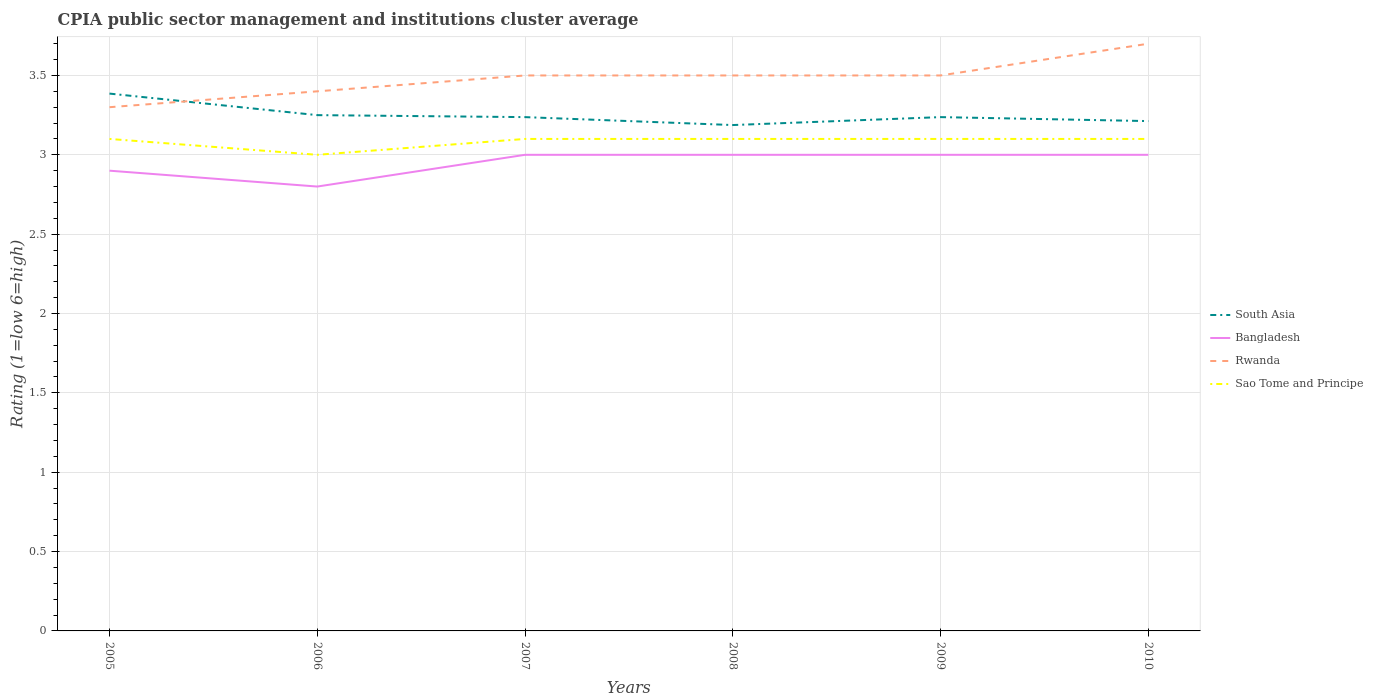How many different coloured lines are there?
Offer a very short reply. 4. Does the line corresponding to South Asia intersect with the line corresponding to Sao Tome and Principe?
Provide a short and direct response. No. In which year was the CPIA rating in South Asia maximum?
Keep it short and to the point. 2008. What is the total CPIA rating in Rwanda in the graph?
Provide a succinct answer. -0.1. What is the difference between the highest and the second highest CPIA rating in Rwanda?
Provide a succinct answer. 0.4. What is the difference between the highest and the lowest CPIA rating in Bangladesh?
Ensure brevity in your answer.  4. How many years are there in the graph?
Offer a terse response. 6. Are the values on the major ticks of Y-axis written in scientific E-notation?
Make the answer very short. No. Does the graph contain grids?
Your response must be concise. Yes. Where does the legend appear in the graph?
Your answer should be compact. Center right. What is the title of the graph?
Give a very brief answer. CPIA public sector management and institutions cluster average. Does "Iceland" appear as one of the legend labels in the graph?
Your answer should be compact. No. What is the Rating (1=low 6=high) of South Asia in 2005?
Offer a terse response. 3.39. What is the Rating (1=low 6=high) in Bangladesh in 2005?
Provide a succinct answer. 2.9. What is the Rating (1=low 6=high) of Sao Tome and Principe in 2005?
Give a very brief answer. 3.1. What is the Rating (1=low 6=high) of South Asia in 2006?
Offer a terse response. 3.25. What is the Rating (1=low 6=high) of Bangladesh in 2006?
Give a very brief answer. 2.8. What is the Rating (1=low 6=high) of Rwanda in 2006?
Keep it short and to the point. 3.4. What is the Rating (1=low 6=high) in South Asia in 2007?
Provide a succinct answer. 3.24. What is the Rating (1=low 6=high) of Bangladesh in 2007?
Provide a succinct answer. 3. What is the Rating (1=low 6=high) in South Asia in 2008?
Your response must be concise. 3.19. What is the Rating (1=low 6=high) in Bangladesh in 2008?
Offer a terse response. 3. What is the Rating (1=low 6=high) in Rwanda in 2008?
Provide a succinct answer. 3.5. What is the Rating (1=low 6=high) of South Asia in 2009?
Give a very brief answer. 3.24. What is the Rating (1=low 6=high) of South Asia in 2010?
Ensure brevity in your answer.  3.21. What is the Rating (1=low 6=high) in Rwanda in 2010?
Give a very brief answer. 3.7. Across all years, what is the maximum Rating (1=low 6=high) of South Asia?
Your answer should be compact. 3.39. Across all years, what is the maximum Rating (1=low 6=high) in Bangladesh?
Your response must be concise. 3. Across all years, what is the maximum Rating (1=low 6=high) in Rwanda?
Offer a terse response. 3.7. Across all years, what is the minimum Rating (1=low 6=high) of South Asia?
Offer a terse response. 3.19. Across all years, what is the minimum Rating (1=low 6=high) of Rwanda?
Your response must be concise. 3.3. What is the total Rating (1=low 6=high) of South Asia in the graph?
Keep it short and to the point. 19.51. What is the total Rating (1=low 6=high) in Rwanda in the graph?
Ensure brevity in your answer.  20.9. What is the total Rating (1=low 6=high) in Sao Tome and Principe in the graph?
Provide a short and direct response. 18.5. What is the difference between the Rating (1=low 6=high) in South Asia in 2005 and that in 2006?
Offer a terse response. 0.14. What is the difference between the Rating (1=low 6=high) in Bangladesh in 2005 and that in 2006?
Ensure brevity in your answer.  0.1. What is the difference between the Rating (1=low 6=high) in Sao Tome and Principe in 2005 and that in 2006?
Your response must be concise. 0.1. What is the difference between the Rating (1=low 6=high) of South Asia in 2005 and that in 2007?
Your answer should be compact. 0.15. What is the difference between the Rating (1=low 6=high) in South Asia in 2005 and that in 2008?
Keep it short and to the point. 0.2. What is the difference between the Rating (1=low 6=high) in South Asia in 2005 and that in 2009?
Offer a very short reply. 0.15. What is the difference between the Rating (1=low 6=high) of Bangladesh in 2005 and that in 2009?
Your answer should be compact. -0.1. What is the difference between the Rating (1=low 6=high) in Rwanda in 2005 and that in 2009?
Provide a succinct answer. -0.2. What is the difference between the Rating (1=low 6=high) of South Asia in 2005 and that in 2010?
Your answer should be compact. 0.17. What is the difference between the Rating (1=low 6=high) in Bangladesh in 2005 and that in 2010?
Your answer should be very brief. -0.1. What is the difference between the Rating (1=low 6=high) of Rwanda in 2005 and that in 2010?
Offer a very short reply. -0.4. What is the difference between the Rating (1=low 6=high) of Sao Tome and Principe in 2005 and that in 2010?
Offer a terse response. 0. What is the difference between the Rating (1=low 6=high) in South Asia in 2006 and that in 2007?
Your response must be concise. 0.01. What is the difference between the Rating (1=low 6=high) in Bangladesh in 2006 and that in 2007?
Ensure brevity in your answer.  -0.2. What is the difference between the Rating (1=low 6=high) in Rwanda in 2006 and that in 2007?
Ensure brevity in your answer.  -0.1. What is the difference between the Rating (1=low 6=high) in Sao Tome and Principe in 2006 and that in 2007?
Provide a succinct answer. -0.1. What is the difference between the Rating (1=low 6=high) of South Asia in 2006 and that in 2008?
Ensure brevity in your answer.  0.06. What is the difference between the Rating (1=low 6=high) in South Asia in 2006 and that in 2009?
Provide a short and direct response. 0.01. What is the difference between the Rating (1=low 6=high) of Bangladesh in 2006 and that in 2009?
Your answer should be very brief. -0.2. What is the difference between the Rating (1=low 6=high) of Rwanda in 2006 and that in 2009?
Offer a terse response. -0.1. What is the difference between the Rating (1=low 6=high) in South Asia in 2006 and that in 2010?
Offer a terse response. 0.04. What is the difference between the Rating (1=low 6=high) of Rwanda in 2006 and that in 2010?
Keep it short and to the point. -0.3. What is the difference between the Rating (1=low 6=high) in Sao Tome and Principe in 2006 and that in 2010?
Make the answer very short. -0.1. What is the difference between the Rating (1=low 6=high) in Bangladesh in 2007 and that in 2008?
Provide a succinct answer. 0. What is the difference between the Rating (1=low 6=high) of Rwanda in 2007 and that in 2008?
Keep it short and to the point. 0. What is the difference between the Rating (1=low 6=high) in Sao Tome and Principe in 2007 and that in 2008?
Keep it short and to the point. 0. What is the difference between the Rating (1=low 6=high) in South Asia in 2007 and that in 2009?
Your response must be concise. 0. What is the difference between the Rating (1=low 6=high) of Bangladesh in 2007 and that in 2009?
Make the answer very short. 0. What is the difference between the Rating (1=low 6=high) in Rwanda in 2007 and that in 2009?
Give a very brief answer. 0. What is the difference between the Rating (1=low 6=high) in South Asia in 2007 and that in 2010?
Offer a very short reply. 0.03. What is the difference between the Rating (1=low 6=high) in Bangladesh in 2007 and that in 2010?
Offer a very short reply. 0. What is the difference between the Rating (1=low 6=high) in Sao Tome and Principe in 2007 and that in 2010?
Offer a very short reply. 0. What is the difference between the Rating (1=low 6=high) of Bangladesh in 2008 and that in 2009?
Give a very brief answer. 0. What is the difference between the Rating (1=low 6=high) in Rwanda in 2008 and that in 2009?
Offer a terse response. 0. What is the difference between the Rating (1=low 6=high) of Sao Tome and Principe in 2008 and that in 2009?
Give a very brief answer. 0. What is the difference between the Rating (1=low 6=high) of South Asia in 2008 and that in 2010?
Offer a very short reply. -0.03. What is the difference between the Rating (1=low 6=high) in Bangladesh in 2008 and that in 2010?
Offer a terse response. 0. What is the difference between the Rating (1=low 6=high) of Rwanda in 2008 and that in 2010?
Keep it short and to the point. -0.2. What is the difference between the Rating (1=low 6=high) in South Asia in 2009 and that in 2010?
Keep it short and to the point. 0.03. What is the difference between the Rating (1=low 6=high) in Rwanda in 2009 and that in 2010?
Offer a terse response. -0.2. What is the difference between the Rating (1=low 6=high) in South Asia in 2005 and the Rating (1=low 6=high) in Bangladesh in 2006?
Your answer should be compact. 0.59. What is the difference between the Rating (1=low 6=high) of South Asia in 2005 and the Rating (1=low 6=high) of Rwanda in 2006?
Provide a succinct answer. -0.01. What is the difference between the Rating (1=low 6=high) in South Asia in 2005 and the Rating (1=low 6=high) in Sao Tome and Principe in 2006?
Provide a short and direct response. 0.39. What is the difference between the Rating (1=low 6=high) of Bangladesh in 2005 and the Rating (1=low 6=high) of Rwanda in 2006?
Offer a terse response. -0.5. What is the difference between the Rating (1=low 6=high) of Rwanda in 2005 and the Rating (1=low 6=high) of Sao Tome and Principe in 2006?
Make the answer very short. 0.3. What is the difference between the Rating (1=low 6=high) of South Asia in 2005 and the Rating (1=low 6=high) of Bangladesh in 2007?
Provide a short and direct response. 0.39. What is the difference between the Rating (1=low 6=high) of South Asia in 2005 and the Rating (1=low 6=high) of Rwanda in 2007?
Ensure brevity in your answer.  -0.11. What is the difference between the Rating (1=low 6=high) of South Asia in 2005 and the Rating (1=low 6=high) of Sao Tome and Principe in 2007?
Provide a succinct answer. 0.29. What is the difference between the Rating (1=low 6=high) of Bangladesh in 2005 and the Rating (1=low 6=high) of Rwanda in 2007?
Ensure brevity in your answer.  -0.6. What is the difference between the Rating (1=low 6=high) in Rwanda in 2005 and the Rating (1=low 6=high) in Sao Tome and Principe in 2007?
Offer a very short reply. 0.2. What is the difference between the Rating (1=low 6=high) in South Asia in 2005 and the Rating (1=low 6=high) in Bangladesh in 2008?
Your answer should be very brief. 0.39. What is the difference between the Rating (1=low 6=high) in South Asia in 2005 and the Rating (1=low 6=high) in Rwanda in 2008?
Your answer should be very brief. -0.11. What is the difference between the Rating (1=low 6=high) of South Asia in 2005 and the Rating (1=low 6=high) of Sao Tome and Principe in 2008?
Offer a terse response. 0.29. What is the difference between the Rating (1=low 6=high) in Bangladesh in 2005 and the Rating (1=low 6=high) in Rwanda in 2008?
Provide a succinct answer. -0.6. What is the difference between the Rating (1=low 6=high) of Rwanda in 2005 and the Rating (1=low 6=high) of Sao Tome and Principe in 2008?
Make the answer very short. 0.2. What is the difference between the Rating (1=low 6=high) of South Asia in 2005 and the Rating (1=low 6=high) of Bangladesh in 2009?
Offer a very short reply. 0.39. What is the difference between the Rating (1=low 6=high) of South Asia in 2005 and the Rating (1=low 6=high) of Rwanda in 2009?
Keep it short and to the point. -0.11. What is the difference between the Rating (1=low 6=high) of South Asia in 2005 and the Rating (1=low 6=high) of Sao Tome and Principe in 2009?
Keep it short and to the point. 0.29. What is the difference between the Rating (1=low 6=high) in Bangladesh in 2005 and the Rating (1=low 6=high) in Sao Tome and Principe in 2009?
Your response must be concise. -0.2. What is the difference between the Rating (1=low 6=high) of South Asia in 2005 and the Rating (1=low 6=high) of Bangladesh in 2010?
Offer a terse response. 0.39. What is the difference between the Rating (1=low 6=high) in South Asia in 2005 and the Rating (1=low 6=high) in Rwanda in 2010?
Make the answer very short. -0.31. What is the difference between the Rating (1=low 6=high) in South Asia in 2005 and the Rating (1=low 6=high) in Sao Tome and Principe in 2010?
Offer a very short reply. 0.29. What is the difference between the Rating (1=low 6=high) in Bangladesh in 2005 and the Rating (1=low 6=high) in Sao Tome and Principe in 2010?
Make the answer very short. -0.2. What is the difference between the Rating (1=low 6=high) in Rwanda in 2005 and the Rating (1=low 6=high) in Sao Tome and Principe in 2010?
Give a very brief answer. 0.2. What is the difference between the Rating (1=low 6=high) in South Asia in 2006 and the Rating (1=low 6=high) in Rwanda in 2007?
Your response must be concise. -0.25. What is the difference between the Rating (1=low 6=high) in South Asia in 2006 and the Rating (1=low 6=high) in Sao Tome and Principe in 2007?
Ensure brevity in your answer.  0.15. What is the difference between the Rating (1=low 6=high) of Bangladesh in 2006 and the Rating (1=low 6=high) of Sao Tome and Principe in 2007?
Keep it short and to the point. -0.3. What is the difference between the Rating (1=low 6=high) in South Asia in 2006 and the Rating (1=low 6=high) in Bangladesh in 2008?
Make the answer very short. 0.25. What is the difference between the Rating (1=low 6=high) in South Asia in 2006 and the Rating (1=low 6=high) in Sao Tome and Principe in 2008?
Keep it short and to the point. 0.15. What is the difference between the Rating (1=low 6=high) of Bangladesh in 2006 and the Rating (1=low 6=high) of Rwanda in 2008?
Offer a terse response. -0.7. What is the difference between the Rating (1=low 6=high) of Rwanda in 2006 and the Rating (1=low 6=high) of Sao Tome and Principe in 2008?
Offer a very short reply. 0.3. What is the difference between the Rating (1=low 6=high) in South Asia in 2006 and the Rating (1=low 6=high) in Sao Tome and Principe in 2009?
Ensure brevity in your answer.  0.15. What is the difference between the Rating (1=low 6=high) of Bangladesh in 2006 and the Rating (1=low 6=high) of Rwanda in 2009?
Offer a terse response. -0.7. What is the difference between the Rating (1=low 6=high) in Rwanda in 2006 and the Rating (1=low 6=high) in Sao Tome and Principe in 2009?
Your answer should be compact. 0.3. What is the difference between the Rating (1=low 6=high) of South Asia in 2006 and the Rating (1=low 6=high) of Bangladesh in 2010?
Your answer should be very brief. 0.25. What is the difference between the Rating (1=low 6=high) of South Asia in 2006 and the Rating (1=low 6=high) of Rwanda in 2010?
Provide a succinct answer. -0.45. What is the difference between the Rating (1=low 6=high) of South Asia in 2006 and the Rating (1=low 6=high) of Sao Tome and Principe in 2010?
Give a very brief answer. 0.15. What is the difference between the Rating (1=low 6=high) in Bangladesh in 2006 and the Rating (1=low 6=high) in Sao Tome and Principe in 2010?
Provide a short and direct response. -0.3. What is the difference between the Rating (1=low 6=high) of South Asia in 2007 and the Rating (1=low 6=high) of Bangladesh in 2008?
Provide a short and direct response. 0.24. What is the difference between the Rating (1=low 6=high) of South Asia in 2007 and the Rating (1=low 6=high) of Rwanda in 2008?
Give a very brief answer. -0.26. What is the difference between the Rating (1=low 6=high) in South Asia in 2007 and the Rating (1=low 6=high) in Sao Tome and Principe in 2008?
Provide a succinct answer. 0.14. What is the difference between the Rating (1=low 6=high) of Rwanda in 2007 and the Rating (1=low 6=high) of Sao Tome and Principe in 2008?
Provide a succinct answer. 0.4. What is the difference between the Rating (1=low 6=high) in South Asia in 2007 and the Rating (1=low 6=high) in Bangladesh in 2009?
Provide a short and direct response. 0.24. What is the difference between the Rating (1=low 6=high) of South Asia in 2007 and the Rating (1=low 6=high) of Rwanda in 2009?
Your answer should be compact. -0.26. What is the difference between the Rating (1=low 6=high) in South Asia in 2007 and the Rating (1=low 6=high) in Sao Tome and Principe in 2009?
Keep it short and to the point. 0.14. What is the difference between the Rating (1=low 6=high) of Bangladesh in 2007 and the Rating (1=low 6=high) of Rwanda in 2009?
Give a very brief answer. -0.5. What is the difference between the Rating (1=low 6=high) of Bangladesh in 2007 and the Rating (1=low 6=high) of Sao Tome and Principe in 2009?
Your answer should be compact. -0.1. What is the difference between the Rating (1=low 6=high) of Rwanda in 2007 and the Rating (1=low 6=high) of Sao Tome and Principe in 2009?
Your response must be concise. 0.4. What is the difference between the Rating (1=low 6=high) of South Asia in 2007 and the Rating (1=low 6=high) of Bangladesh in 2010?
Offer a very short reply. 0.24. What is the difference between the Rating (1=low 6=high) of South Asia in 2007 and the Rating (1=low 6=high) of Rwanda in 2010?
Keep it short and to the point. -0.46. What is the difference between the Rating (1=low 6=high) in South Asia in 2007 and the Rating (1=low 6=high) in Sao Tome and Principe in 2010?
Provide a succinct answer. 0.14. What is the difference between the Rating (1=low 6=high) in Bangladesh in 2007 and the Rating (1=low 6=high) in Rwanda in 2010?
Provide a succinct answer. -0.7. What is the difference between the Rating (1=low 6=high) of South Asia in 2008 and the Rating (1=low 6=high) of Bangladesh in 2009?
Provide a short and direct response. 0.19. What is the difference between the Rating (1=low 6=high) in South Asia in 2008 and the Rating (1=low 6=high) in Rwanda in 2009?
Offer a very short reply. -0.31. What is the difference between the Rating (1=low 6=high) of South Asia in 2008 and the Rating (1=low 6=high) of Sao Tome and Principe in 2009?
Keep it short and to the point. 0.09. What is the difference between the Rating (1=low 6=high) of Bangladesh in 2008 and the Rating (1=low 6=high) of Rwanda in 2009?
Make the answer very short. -0.5. What is the difference between the Rating (1=low 6=high) of Bangladesh in 2008 and the Rating (1=low 6=high) of Sao Tome and Principe in 2009?
Provide a short and direct response. -0.1. What is the difference between the Rating (1=low 6=high) in South Asia in 2008 and the Rating (1=low 6=high) in Bangladesh in 2010?
Provide a short and direct response. 0.19. What is the difference between the Rating (1=low 6=high) of South Asia in 2008 and the Rating (1=low 6=high) of Rwanda in 2010?
Your response must be concise. -0.51. What is the difference between the Rating (1=low 6=high) in South Asia in 2008 and the Rating (1=low 6=high) in Sao Tome and Principe in 2010?
Make the answer very short. 0.09. What is the difference between the Rating (1=low 6=high) of Bangladesh in 2008 and the Rating (1=low 6=high) of Sao Tome and Principe in 2010?
Offer a terse response. -0.1. What is the difference between the Rating (1=low 6=high) in Rwanda in 2008 and the Rating (1=low 6=high) in Sao Tome and Principe in 2010?
Offer a terse response. 0.4. What is the difference between the Rating (1=low 6=high) of South Asia in 2009 and the Rating (1=low 6=high) of Bangladesh in 2010?
Offer a very short reply. 0.24. What is the difference between the Rating (1=low 6=high) of South Asia in 2009 and the Rating (1=low 6=high) of Rwanda in 2010?
Offer a very short reply. -0.46. What is the difference between the Rating (1=low 6=high) in South Asia in 2009 and the Rating (1=low 6=high) in Sao Tome and Principe in 2010?
Give a very brief answer. 0.14. What is the difference between the Rating (1=low 6=high) in Bangladesh in 2009 and the Rating (1=low 6=high) in Sao Tome and Principe in 2010?
Provide a succinct answer. -0.1. What is the difference between the Rating (1=low 6=high) of Rwanda in 2009 and the Rating (1=low 6=high) of Sao Tome and Principe in 2010?
Keep it short and to the point. 0.4. What is the average Rating (1=low 6=high) of South Asia per year?
Make the answer very short. 3.25. What is the average Rating (1=low 6=high) in Bangladesh per year?
Keep it short and to the point. 2.95. What is the average Rating (1=low 6=high) in Rwanda per year?
Ensure brevity in your answer.  3.48. What is the average Rating (1=low 6=high) of Sao Tome and Principe per year?
Offer a very short reply. 3.08. In the year 2005, what is the difference between the Rating (1=low 6=high) of South Asia and Rating (1=low 6=high) of Bangladesh?
Provide a short and direct response. 0.49. In the year 2005, what is the difference between the Rating (1=low 6=high) of South Asia and Rating (1=low 6=high) of Rwanda?
Provide a succinct answer. 0.09. In the year 2005, what is the difference between the Rating (1=low 6=high) of South Asia and Rating (1=low 6=high) of Sao Tome and Principe?
Offer a terse response. 0.29. In the year 2005, what is the difference between the Rating (1=low 6=high) in Bangladesh and Rating (1=low 6=high) in Rwanda?
Ensure brevity in your answer.  -0.4. In the year 2005, what is the difference between the Rating (1=low 6=high) of Rwanda and Rating (1=low 6=high) of Sao Tome and Principe?
Give a very brief answer. 0.2. In the year 2006, what is the difference between the Rating (1=low 6=high) in South Asia and Rating (1=low 6=high) in Bangladesh?
Give a very brief answer. 0.45. In the year 2006, what is the difference between the Rating (1=low 6=high) in South Asia and Rating (1=low 6=high) in Rwanda?
Offer a very short reply. -0.15. In the year 2006, what is the difference between the Rating (1=low 6=high) of Bangladesh and Rating (1=low 6=high) of Rwanda?
Your answer should be very brief. -0.6. In the year 2006, what is the difference between the Rating (1=low 6=high) of Rwanda and Rating (1=low 6=high) of Sao Tome and Principe?
Offer a terse response. 0.4. In the year 2007, what is the difference between the Rating (1=low 6=high) of South Asia and Rating (1=low 6=high) of Bangladesh?
Ensure brevity in your answer.  0.24. In the year 2007, what is the difference between the Rating (1=low 6=high) in South Asia and Rating (1=low 6=high) in Rwanda?
Keep it short and to the point. -0.26. In the year 2007, what is the difference between the Rating (1=low 6=high) in South Asia and Rating (1=low 6=high) in Sao Tome and Principe?
Offer a very short reply. 0.14. In the year 2007, what is the difference between the Rating (1=low 6=high) in Bangladesh and Rating (1=low 6=high) in Rwanda?
Provide a short and direct response. -0.5. In the year 2007, what is the difference between the Rating (1=low 6=high) in Bangladesh and Rating (1=low 6=high) in Sao Tome and Principe?
Ensure brevity in your answer.  -0.1. In the year 2007, what is the difference between the Rating (1=low 6=high) of Rwanda and Rating (1=low 6=high) of Sao Tome and Principe?
Your answer should be compact. 0.4. In the year 2008, what is the difference between the Rating (1=low 6=high) in South Asia and Rating (1=low 6=high) in Bangladesh?
Your answer should be very brief. 0.19. In the year 2008, what is the difference between the Rating (1=low 6=high) of South Asia and Rating (1=low 6=high) of Rwanda?
Your response must be concise. -0.31. In the year 2008, what is the difference between the Rating (1=low 6=high) of South Asia and Rating (1=low 6=high) of Sao Tome and Principe?
Give a very brief answer. 0.09. In the year 2008, what is the difference between the Rating (1=low 6=high) of Rwanda and Rating (1=low 6=high) of Sao Tome and Principe?
Your answer should be very brief. 0.4. In the year 2009, what is the difference between the Rating (1=low 6=high) in South Asia and Rating (1=low 6=high) in Bangladesh?
Your answer should be compact. 0.24. In the year 2009, what is the difference between the Rating (1=low 6=high) in South Asia and Rating (1=low 6=high) in Rwanda?
Ensure brevity in your answer.  -0.26. In the year 2009, what is the difference between the Rating (1=low 6=high) in South Asia and Rating (1=low 6=high) in Sao Tome and Principe?
Ensure brevity in your answer.  0.14. In the year 2009, what is the difference between the Rating (1=low 6=high) in Bangladesh and Rating (1=low 6=high) in Rwanda?
Your answer should be very brief. -0.5. In the year 2009, what is the difference between the Rating (1=low 6=high) in Rwanda and Rating (1=low 6=high) in Sao Tome and Principe?
Your answer should be very brief. 0.4. In the year 2010, what is the difference between the Rating (1=low 6=high) of South Asia and Rating (1=low 6=high) of Bangladesh?
Ensure brevity in your answer.  0.21. In the year 2010, what is the difference between the Rating (1=low 6=high) in South Asia and Rating (1=low 6=high) in Rwanda?
Your response must be concise. -0.49. In the year 2010, what is the difference between the Rating (1=low 6=high) in South Asia and Rating (1=low 6=high) in Sao Tome and Principe?
Your response must be concise. 0.11. In the year 2010, what is the difference between the Rating (1=low 6=high) in Bangladesh and Rating (1=low 6=high) in Sao Tome and Principe?
Provide a succinct answer. -0.1. In the year 2010, what is the difference between the Rating (1=low 6=high) in Rwanda and Rating (1=low 6=high) in Sao Tome and Principe?
Keep it short and to the point. 0.6. What is the ratio of the Rating (1=low 6=high) of South Asia in 2005 to that in 2006?
Offer a very short reply. 1.04. What is the ratio of the Rating (1=low 6=high) in Bangladesh in 2005 to that in 2006?
Offer a terse response. 1.04. What is the ratio of the Rating (1=low 6=high) in Rwanda in 2005 to that in 2006?
Your answer should be compact. 0.97. What is the ratio of the Rating (1=low 6=high) of Sao Tome and Principe in 2005 to that in 2006?
Your answer should be compact. 1.03. What is the ratio of the Rating (1=low 6=high) in South Asia in 2005 to that in 2007?
Make the answer very short. 1.05. What is the ratio of the Rating (1=low 6=high) in Bangladesh in 2005 to that in 2007?
Provide a succinct answer. 0.97. What is the ratio of the Rating (1=low 6=high) in Rwanda in 2005 to that in 2007?
Keep it short and to the point. 0.94. What is the ratio of the Rating (1=low 6=high) in South Asia in 2005 to that in 2008?
Provide a short and direct response. 1.06. What is the ratio of the Rating (1=low 6=high) in Bangladesh in 2005 to that in 2008?
Offer a very short reply. 0.97. What is the ratio of the Rating (1=low 6=high) of Rwanda in 2005 to that in 2008?
Offer a terse response. 0.94. What is the ratio of the Rating (1=low 6=high) of Sao Tome and Principe in 2005 to that in 2008?
Keep it short and to the point. 1. What is the ratio of the Rating (1=low 6=high) in South Asia in 2005 to that in 2009?
Ensure brevity in your answer.  1.05. What is the ratio of the Rating (1=low 6=high) in Bangladesh in 2005 to that in 2009?
Provide a short and direct response. 0.97. What is the ratio of the Rating (1=low 6=high) of Rwanda in 2005 to that in 2009?
Give a very brief answer. 0.94. What is the ratio of the Rating (1=low 6=high) in Sao Tome and Principe in 2005 to that in 2009?
Keep it short and to the point. 1. What is the ratio of the Rating (1=low 6=high) in South Asia in 2005 to that in 2010?
Keep it short and to the point. 1.05. What is the ratio of the Rating (1=low 6=high) of Bangladesh in 2005 to that in 2010?
Keep it short and to the point. 0.97. What is the ratio of the Rating (1=low 6=high) of Rwanda in 2005 to that in 2010?
Offer a very short reply. 0.89. What is the ratio of the Rating (1=low 6=high) in Bangladesh in 2006 to that in 2007?
Your response must be concise. 0.93. What is the ratio of the Rating (1=low 6=high) in Rwanda in 2006 to that in 2007?
Offer a terse response. 0.97. What is the ratio of the Rating (1=low 6=high) of South Asia in 2006 to that in 2008?
Offer a very short reply. 1.02. What is the ratio of the Rating (1=low 6=high) of Bangladesh in 2006 to that in 2008?
Offer a very short reply. 0.93. What is the ratio of the Rating (1=low 6=high) of Rwanda in 2006 to that in 2008?
Provide a short and direct response. 0.97. What is the ratio of the Rating (1=low 6=high) in South Asia in 2006 to that in 2009?
Provide a short and direct response. 1. What is the ratio of the Rating (1=low 6=high) in Bangladesh in 2006 to that in 2009?
Give a very brief answer. 0.93. What is the ratio of the Rating (1=low 6=high) in Rwanda in 2006 to that in 2009?
Keep it short and to the point. 0.97. What is the ratio of the Rating (1=low 6=high) of Sao Tome and Principe in 2006 to that in 2009?
Offer a very short reply. 0.97. What is the ratio of the Rating (1=low 6=high) of South Asia in 2006 to that in 2010?
Provide a short and direct response. 1.01. What is the ratio of the Rating (1=low 6=high) in Rwanda in 2006 to that in 2010?
Keep it short and to the point. 0.92. What is the ratio of the Rating (1=low 6=high) in Sao Tome and Principe in 2006 to that in 2010?
Your answer should be very brief. 0.97. What is the ratio of the Rating (1=low 6=high) in South Asia in 2007 to that in 2008?
Offer a terse response. 1.02. What is the ratio of the Rating (1=low 6=high) in Bangladesh in 2007 to that in 2008?
Your answer should be very brief. 1. What is the ratio of the Rating (1=low 6=high) of Rwanda in 2007 to that in 2008?
Give a very brief answer. 1. What is the ratio of the Rating (1=low 6=high) of Sao Tome and Principe in 2007 to that in 2008?
Ensure brevity in your answer.  1. What is the ratio of the Rating (1=low 6=high) of South Asia in 2007 to that in 2009?
Provide a succinct answer. 1. What is the ratio of the Rating (1=low 6=high) of Bangladesh in 2007 to that in 2009?
Offer a very short reply. 1. What is the ratio of the Rating (1=low 6=high) in Rwanda in 2007 to that in 2009?
Ensure brevity in your answer.  1. What is the ratio of the Rating (1=low 6=high) in Rwanda in 2007 to that in 2010?
Provide a succinct answer. 0.95. What is the ratio of the Rating (1=low 6=high) in South Asia in 2008 to that in 2009?
Your answer should be very brief. 0.98. What is the ratio of the Rating (1=low 6=high) in Bangladesh in 2008 to that in 2009?
Keep it short and to the point. 1. What is the ratio of the Rating (1=low 6=high) of Rwanda in 2008 to that in 2009?
Your response must be concise. 1. What is the ratio of the Rating (1=low 6=high) of Rwanda in 2008 to that in 2010?
Your answer should be compact. 0.95. What is the ratio of the Rating (1=low 6=high) of Rwanda in 2009 to that in 2010?
Provide a short and direct response. 0.95. What is the difference between the highest and the second highest Rating (1=low 6=high) of South Asia?
Your response must be concise. 0.14. What is the difference between the highest and the lowest Rating (1=low 6=high) of South Asia?
Keep it short and to the point. 0.2. What is the difference between the highest and the lowest Rating (1=low 6=high) of Rwanda?
Your answer should be compact. 0.4. What is the difference between the highest and the lowest Rating (1=low 6=high) in Sao Tome and Principe?
Your answer should be compact. 0.1. 